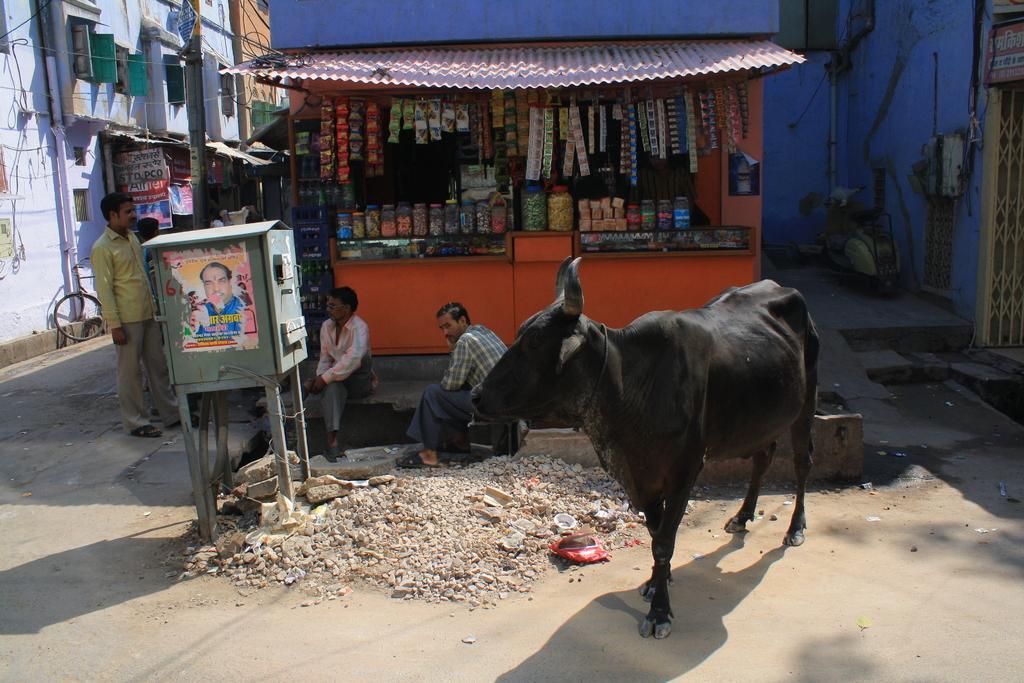How would you summarize this image in a sentence or two? In this image, I can see a cow, two persons sitting and two persons standing. There is a shop with food packets and another person in the shop. On the left side of the image, I can see the buildings with windows, current pole and a bicycle. In front of the shop, I can see a metal box with stand and there are rocks. On the right side of the image, I can see a motorbike which is parked, iron grilles, name board and an object attached to the building wall. 